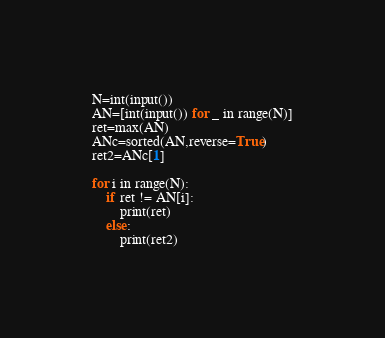<code> <loc_0><loc_0><loc_500><loc_500><_Python_>N=int(input())
AN=[int(input()) for _ in range(N)]
ret=max(AN)
ANc=sorted(AN,reverse=True)
ret2=ANc[1]

for i in range(N):
    if ret != AN[i]:
        print(ret)
    else:
        print(ret2)
</code> 